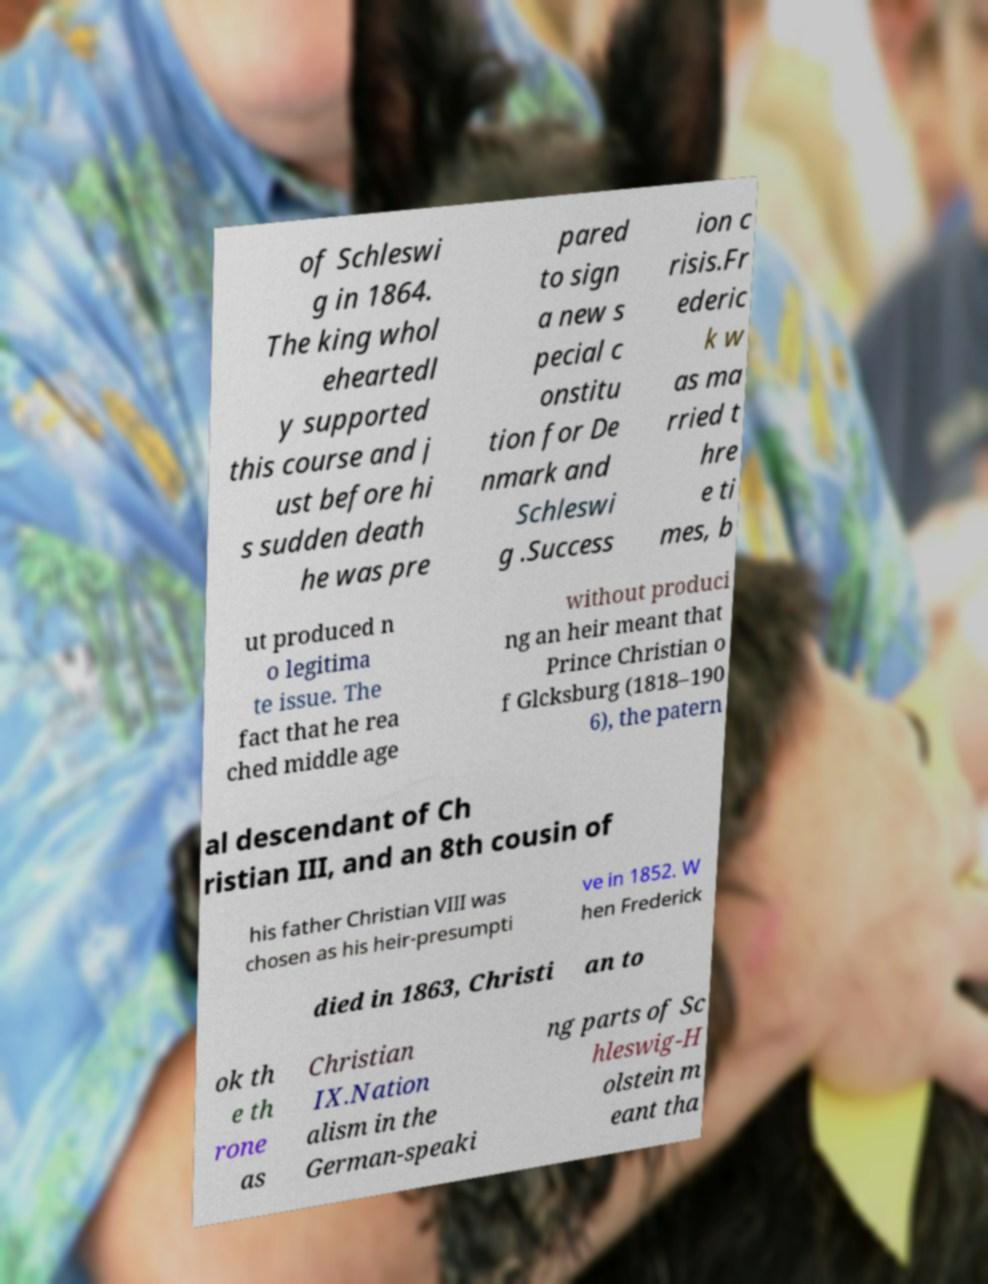Can you read and provide the text displayed in the image?This photo seems to have some interesting text. Can you extract and type it out for me? of Schleswi g in 1864. The king whol eheartedl y supported this course and j ust before hi s sudden death he was pre pared to sign a new s pecial c onstitu tion for De nmark and Schleswi g .Success ion c risis.Fr ederic k w as ma rried t hre e ti mes, b ut produced n o legitima te issue. The fact that he rea ched middle age without produci ng an heir meant that Prince Christian o f Glcksburg (1818–190 6), the patern al descendant of Ch ristian III, and an 8th cousin of his father Christian VIII was chosen as his heir-presumpti ve in 1852. W hen Frederick died in 1863, Christi an to ok th e th rone as Christian IX.Nation alism in the German-speaki ng parts of Sc hleswig-H olstein m eant tha 